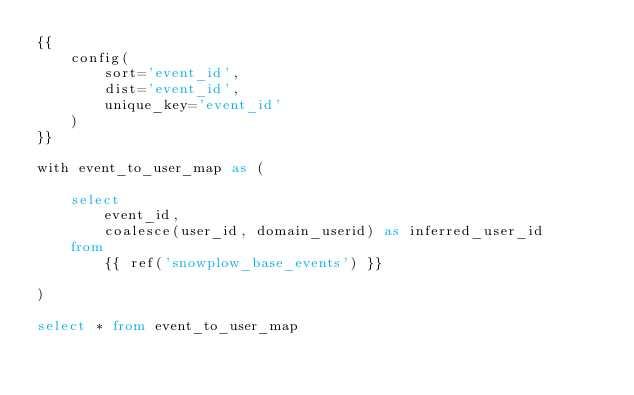Convert code to text. <code><loc_0><loc_0><loc_500><loc_500><_SQL_>{{
    config(
        sort='event_id',
        dist='event_id',
        unique_key='event_id'
    )
}}

with event_to_user_map as (

    select 
        event_id,
        coalesce(user_id, domain_userid) as inferred_user_id
    from
        {{ ref('snowplow_base_events') }}

)

select * from event_to_user_map
</code> 